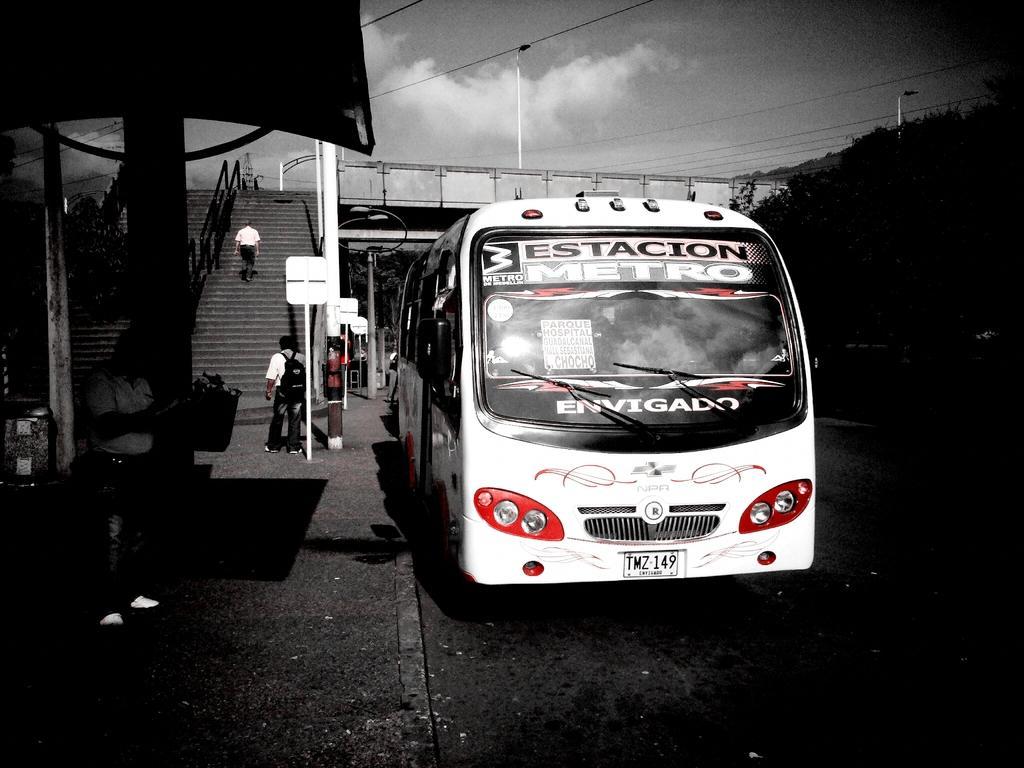Could you give a brief overview of what you see in this image? In this image we can see the shed and there is the person standing. And there is the vehicle on the road. There is the person walking on the stairs. And there are boards, street lights, railing, trees and the sky. 